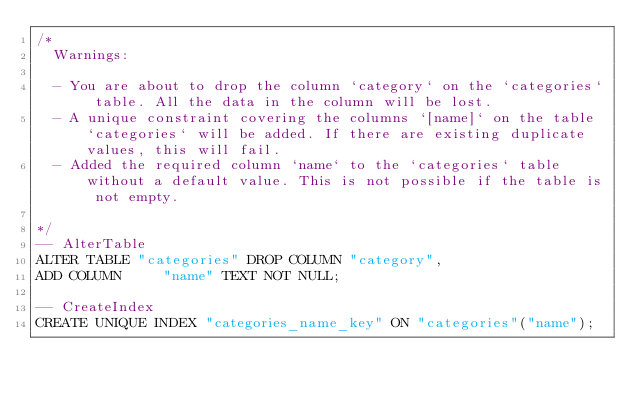Convert code to text. <code><loc_0><loc_0><loc_500><loc_500><_SQL_>/*
  Warnings:

  - You are about to drop the column `category` on the `categories` table. All the data in the column will be lost.
  - A unique constraint covering the columns `[name]` on the table `categories` will be added. If there are existing duplicate values, this will fail.
  - Added the required column `name` to the `categories` table without a default value. This is not possible if the table is not empty.

*/
-- AlterTable
ALTER TABLE "categories" DROP COLUMN "category",
ADD COLUMN     "name" TEXT NOT NULL;

-- CreateIndex
CREATE UNIQUE INDEX "categories_name_key" ON "categories"("name");
</code> 